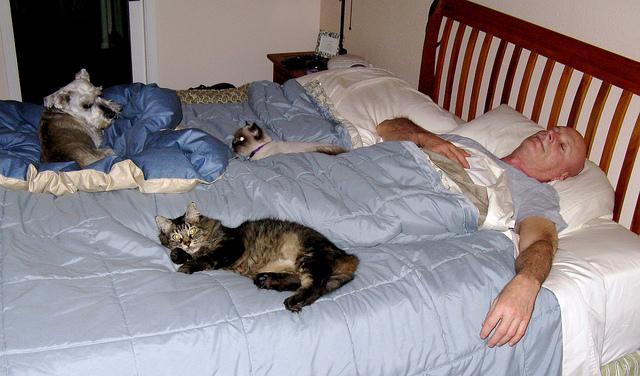How many species rest here? three 